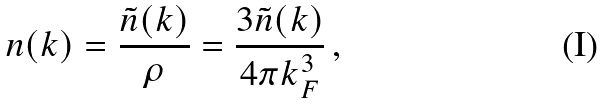Convert formula to latex. <formula><loc_0><loc_0><loc_500><loc_500>n ( k ) = \frac { \tilde { n } ( k ) } { \rho } = \frac { 3 \tilde { n } ( k ) } { 4 \pi k _ { F } ^ { 3 } } \, ,</formula> 